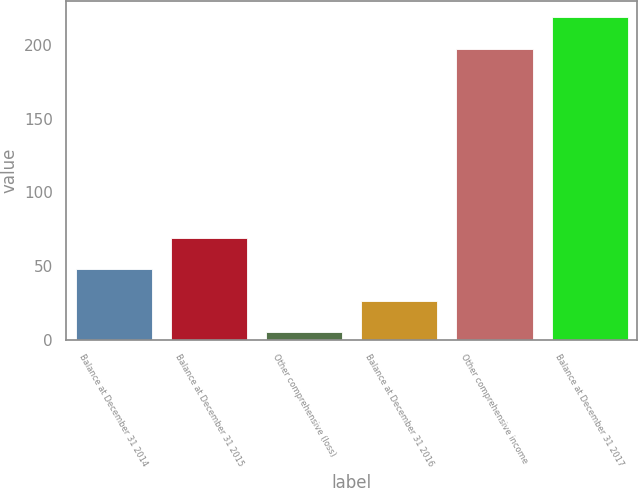Convert chart to OTSL. <chart><loc_0><loc_0><loc_500><loc_500><bar_chart><fcel>Balance at December 31 2014<fcel>Balance at December 31 2015<fcel>Other comprehensive (loss)<fcel>Balance at December 31 2016<fcel>Other comprehensive income<fcel>Balance at December 31 2017<nl><fcel>47.8<fcel>69.2<fcel>5<fcel>26.4<fcel>197<fcel>219<nl></chart> 